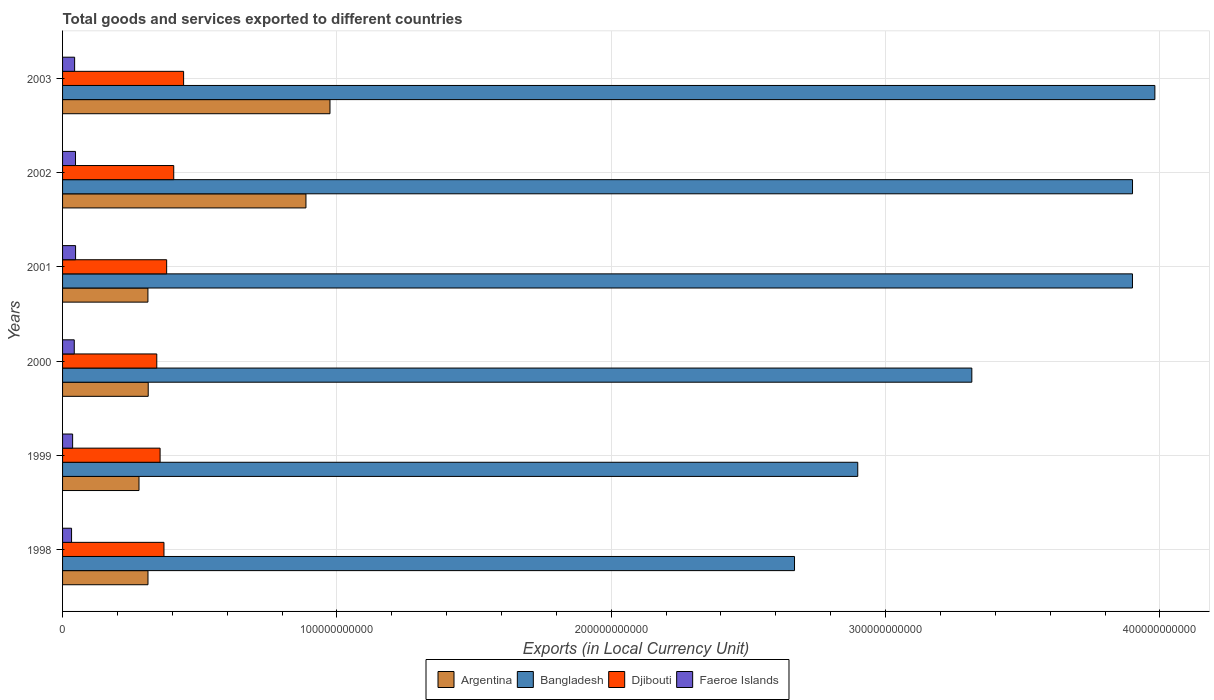Are the number of bars on each tick of the Y-axis equal?
Your response must be concise. Yes. How many bars are there on the 2nd tick from the top?
Keep it short and to the point. 4. How many bars are there on the 6th tick from the bottom?
Your answer should be very brief. 4. What is the label of the 4th group of bars from the top?
Offer a terse response. 2000. In how many cases, is the number of bars for a given year not equal to the number of legend labels?
Keep it short and to the point. 0. What is the Amount of goods and services exports in Djibouti in 2003?
Give a very brief answer. 4.41e+1. Across all years, what is the maximum Amount of goods and services exports in Faeroe Islands?
Your answer should be compact. 4.74e+09. Across all years, what is the minimum Amount of goods and services exports in Bangladesh?
Give a very brief answer. 2.67e+11. What is the total Amount of goods and services exports in Faeroe Islands in the graph?
Make the answer very short. 2.51e+1. What is the difference between the Amount of goods and services exports in Bangladesh in 2002 and that in 2003?
Offer a very short reply. -8.15e+09. What is the difference between the Amount of goods and services exports in Djibouti in 2000 and the Amount of goods and services exports in Faeroe Islands in 2001?
Offer a terse response. 2.96e+1. What is the average Amount of goods and services exports in Faeroe Islands per year?
Keep it short and to the point. 4.18e+09. In the year 1998, what is the difference between the Amount of goods and services exports in Bangladesh and Amount of goods and services exports in Faeroe Islands?
Make the answer very short. 2.64e+11. In how many years, is the Amount of goods and services exports in Argentina greater than 200000000000 LCU?
Make the answer very short. 0. What is the ratio of the Amount of goods and services exports in Bangladesh in 2000 to that in 2002?
Make the answer very short. 0.85. Is the Amount of goods and services exports in Djibouti in 1999 less than that in 2002?
Your response must be concise. Yes. Is the difference between the Amount of goods and services exports in Bangladesh in 1998 and 2003 greater than the difference between the Amount of goods and services exports in Faeroe Islands in 1998 and 2003?
Give a very brief answer. No. What is the difference between the highest and the second highest Amount of goods and services exports in Djibouti?
Your answer should be compact. 3.60e+09. What is the difference between the highest and the lowest Amount of goods and services exports in Djibouti?
Make the answer very short. 9.78e+09. In how many years, is the Amount of goods and services exports in Argentina greater than the average Amount of goods and services exports in Argentina taken over all years?
Give a very brief answer. 2. Is the sum of the Amount of goods and services exports in Faeroe Islands in 1999 and 2001 greater than the maximum Amount of goods and services exports in Argentina across all years?
Your answer should be compact. No. Is it the case that in every year, the sum of the Amount of goods and services exports in Faeroe Islands and Amount of goods and services exports in Djibouti is greater than the sum of Amount of goods and services exports in Argentina and Amount of goods and services exports in Bangladesh?
Give a very brief answer. Yes. What does the 4th bar from the bottom in 2002 represents?
Provide a succinct answer. Faeroe Islands. How many years are there in the graph?
Make the answer very short. 6. What is the difference between two consecutive major ticks on the X-axis?
Provide a succinct answer. 1.00e+11. Are the values on the major ticks of X-axis written in scientific E-notation?
Provide a short and direct response. No. Does the graph contain any zero values?
Offer a very short reply. No. Does the graph contain grids?
Keep it short and to the point. Yes. How are the legend labels stacked?
Your response must be concise. Horizontal. What is the title of the graph?
Ensure brevity in your answer.  Total goods and services exported to different countries. What is the label or title of the X-axis?
Offer a very short reply. Exports (in Local Currency Unit). What is the label or title of the Y-axis?
Provide a short and direct response. Years. What is the Exports (in Local Currency Unit) of Argentina in 1998?
Ensure brevity in your answer.  3.11e+1. What is the Exports (in Local Currency Unit) in Bangladesh in 1998?
Give a very brief answer. 2.67e+11. What is the Exports (in Local Currency Unit) in Djibouti in 1998?
Offer a terse response. 3.70e+1. What is the Exports (in Local Currency Unit) of Faeroe Islands in 1998?
Make the answer very short. 3.28e+09. What is the Exports (in Local Currency Unit) of Argentina in 1999?
Make the answer very short. 2.79e+1. What is the Exports (in Local Currency Unit) of Bangladesh in 1999?
Your response must be concise. 2.90e+11. What is the Exports (in Local Currency Unit) of Djibouti in 1999?
Make the answer very short. 3.56e+1. What is the Exports (in Local Currency Unit) of Faeroe Islands in 1999?
Offer a terse response. 3.66e+09. What is the Exports (in Local Currency Unit) of Argentina in 2000?
Ensure brevity in your answer.  3.12e+1. What is the Exports (in Local Currency Unit) in Bangladesh in 2000?
Offer a terse response. 3.31e+11. What is the Exports (in Local Currency Unit) of Djibouti in 2000?
Keep it short and to the point. 3.43e+1. What is the Exports (in Local Currency Unit) in Faeroe Islands in 2000?
Your answer should be very brief. 4.26e+09. What is the Exports (in Local Currency Unit) in Argentina in 2001?
Provide a succinct answer. 3.11e+1. What is the Exports (in Local Currency Unit) in Bangladesh in 2001?
Provide a succinct answer. 3.90e+11. What is the Exports (in Local Currency Unit) of Djibouti in 2001?
Provide a succinct answer. 3.79e+1. What is the Exports (in Local Currency Unit) in Faeroe Islands in 2001?
Your answer should be very brief. 4.74e+09. What is the Exports (in Local Currency Unit) of Argentina in 2002?
Your response must be concise. 8.87e+1. What is the Exports (in Local Currency Unit) of Bangladesh in 2002?
Provide a succinct answer. 3.90e+11. What is the Exports (in Local Currency Unit) in Djibouti in 2002?
Offer a terse response. 4.05e+1. What is the Exports (in Local Currency Unit) in Faeroe Islands in 2002?
Offer a very short reply. 4.72e+09. What is the Exports (in Local Currency Unit) of Argentina in 2003?
Provide a succinct answer. 9.75e+1. What is the Exports (in Local Currency Unit) of Bangladesh in 2003?
Provide a succinct answer. 3.98e+11. What is the Exports (in Local Currency Unit) in Djibouti in 2003?
Give a very brief answer. 4.41e+1. What is the Exports (in Local Currency Unit) in Faeroe Islands in 2003?
Give a very brief answer. 4.40e+09. Across all years, what is the maximum Exports (in Local Currency Unit) in Argentina?
Provide a succinct answer. 9.75e+1. Across all years, what is the maximum Exports (in Local Currency Unit) in Bangladesh?
Your answer should be compact. 3.98e+11. Across all years, what is the maximum Exports (in Local Currency Unit) in Djibouti?
Offer a very short reply. 4.41e+1. Across all years, what is the maximum Exports (in Local Currency Unit) in Faeroe Islands?
Your response must be concise. 4.74e+09. Across all years, what is the minimum Exports (in Local Currency Unit) of Argentina?
Give a very brief answer. 2.79e+1. Across all years, what is the minimum Exports (in Local Currency Unit) in Bangladesh?
Give a very brief answer. 2.67e+11. Across all years, what is the minimum Exports (in Local Currency Unit) in Djibouti?
Your answer should be compact. 3.43e+1. Across all years, what is the minimum Exports (in Local Currency Unit) of Faeroe Islands?
Make the answer very short. 3.28e+09. What is the total Exports (in Local Currency Unit) of Argentina in the graph?
Your response must be concise. 3.08e+11. What is the total Exports (in Local Currency Unit) in Bangladesh in the graph?
Your answer should be very brief. 2.07e+12. What is the total Exports (in Local Currency Unit) in Djibouti in the graph?
Your response must be concise. 2.29e+11. What is the total Exports (in Local Currency Unit) of Faeroe Islands in the graph?
Provide a succinct answer. 2.51e+1. What is the difference between the Exports (in Local Currency Unit) of Argentina in 1998 and that in 1999?
Make the answer very short. 3.27e+09. What is the difference between the Exports (in Local Currency Unit) in Bangladesh in 1998 and that in 1999?
Offer a terse response. -2.31e+1. What is the difference between the Exports (in Local Currency Unit) in Djibouti in 1998 and that in 1999?
Give a very brief answer. 1.41e+09. What is the difference between the Exports (in Local Currency Unit) in Faeroe Islands in 1998 and that in 1999?
Ensure brevity in your answer.  -3.83e+08. What is the difference between the Exports (in Local Currency Unit) of Argentina in 1998 and that in 2000?
Make the answer very short. -8.68e+07. What is the difference between the Exports (in Local Currency Unit) in Bangladesh in 1998 and that in 2000?
Provide a short and direct response. -6.46e+1. What is the difference between the Exports (in Local Currency Unit) in Djibouti in 1998 and that in 2000?
Ensure brevity in your answer.  2.62e+09. What is the difference between the Exports (in Local Currency Unit) in Faeroe Islands in 1998 and that in 2000?
Provide a short and direct response. -9.84e+08. What is the difference between the Exports (in Local Currency Unit) in Argentina in 1998 and that in 2001?
Ensure brevity in your answer.  2.42e+07. What is the difference between the Exports (in Local Currency Unit) in Bangladesh in 1998 and that in 2001?
Offer a terse response. -1.23e+11. What is the difference between the Exports (in Local Currency Unit) in Djibouti in 1998 and that in 2001?
Your response must be concise. -9.75e+08. What is the difference between the Exports (in Local Currency Unit) in Faeroe Islands in 1998 and that in 2001?
Give a very brief answer. -1.46e+09. What is the difference between the Exports (in Local Currency Unit) in Argentina in 1998 and that in 2002?
Make the answer very short. -5.76e+1. What is the difference between the Exports (in Local Currency Unit) of Bangladesh in 1998 and that in 2002?
Keep it short and to the point. -1.23e+11. What is the difference between the Exports (in Local Currency Unit) of Djibouti in 1998 and that in 2002?
Offer a very short reply. -3.56e+09. What is the difference between the Exports (in Local Currency Unit) of Faeroe Islands in 1998 and that in 2002?
Provide a succinct answer. -1.44e+09. What is the difference between the Exports (in Local Currency Unit) of Argentina in 1998 and that in 2003?
Keep it short and to the point. -6.63e+1. What is the difference between the Exports (in Local Currency Unit) of Bangladesh in 1998 and that in 2003?
Offer a terse response. -1.31e+11. What is the difference between the Exports (in Local Currency Unit) of Djibouti in 1998 and that in 2003?
Provide a short and direct response. -7.16e+09. What is the difference between the Exports (in Local Currency Unit) in Faeroe Islands in 1998 and that in 2003?
Offer a very short reply. -1.12e+09. What is the difference between the Exports (in Local Currency Unit) in Argentina in 1999 and that in 2000?
Your response must be concise. -3.36e+09. What is the difference between the Exports (in Local Currency Unit) in Bangladesh in 1999 and that in 2000?
Your response must be concise. -4.16e+1. What is the difference between the Exports (in Local Currency Unit) of Djibouti in 1999 and that in 2000?
Keep it short and to the point. 1.21e+09. What is the difference between the Exports (in Local Currency Unit) of Faeroe Islands in 1999 and that in 2000?
Ensure brevity in your answer.  -6.01e+08. What is the difference between the Exports (in Local Currency Unit) of Argentina in 1999 and that in 2001?
Offer a terse response. -3.25e+09. What is the difference between the Exports (in Local Currency Unit) in Bangladesh in 1999 and that in 2001?
Give a very brief answer. -1.00e+11. What is the difference between the Exports (in Local Currency Unit) in Djibouti in 1999 and that in 2001?
Keep it short and to the point. -2.39e+09. What is the difference between the Exports (in Local Currency Unit) in Faeroe Islands in 1999 and that in 2001?
Provide a short and direct response. -1.08e+09. What is the difference between the Exports (in Local Currency Unit) in Argentina in 1999 and that in 2002?
Provide a succinct answer. -6.09e+1. What is the difference between the Exports (in Local Currency Unit) in Bangladesh in 1999 and that in 2002?
Provide a short and direct response. -1.00e+11. What is the difference between the Exports (in Local Currency Unit) of Djibouti in 1999 and that in 2002?
Ensure brevity in your answer.  -4.97e+09. What is the difference between the Exports (in Local Currency Unit) in Faeroe Islands in 1999 and that in 2002?
Provide a succinct answer. -1.06e+09. What is the difference between the Exports (in Local Currency Unit) in Argentina in 1999 and that in 2003?
Make the answer very short. -6.96e+1. What is the difference between the Exports (in Local Currency Unit) of Bangladesh in 1999 and that in 2003?
Ensure brevity in your answer.  -1.08e+11. What is the difference between the Exports (in Local Currency Unit) in Djibouti in 1999 and that in 2003?
Give a very brief answer. -8.57e+09. What is the difference between the Exports (in Local Currency Unit) of Faeroe Islands in 1999 and that in 2003?
Your response must be concise. -7.34e+08. What is the difference between the Exports (in Local Currency Unit) of Argentina in 2000 and that in 2001?
Your answer should be compact. 1.11e+08. What is the difference between the Exports (in Local Currency Unit) of Bangladesh in 2000 and that in 2001?
Provide a succinct answer. -5.86e+1. What is the difference between the Exports (in Local Currency Unit) of Djibouti in 2000 and that in 2001?
Make the answer very short. -3.60e+09. What is the difference between the Exports (in Local Currency Unit) in Faeroe Islands in 2000 and that in 2001?
Ensure brevity in your answer.  -4.78e+08. What is the difference between the Exports (in Local Currency Unit) in Argentina in 2000 and that in 2002?
Offer a terse response. -5.75e+1. What is the difference between the Exports (in Local Currency Unit) in Bangladesh in 2000 and that in 2002?
Keep it short and to the point. -5.86e+1. What is the difference between the Exports (in Local Currency Unit) in Djibouti in 2000 and that in 2002?
Your response must be concise. -6.18e+09. What is the difference between the Exports (in Local Currency Unit) of Faeroe Islands in 2000 and that in 2002?
Provide a short and direct response. -4.54e+08. What is the difference between the Exports (in Local Currency Unit) in Argentina in 2000 and that in 2003?
Give a very brief answer. -6.63e+1. What is the difference between the Exports (in Local Currency Unit) of Bangladesh in 2000 and that in 2003?
Keep it short and to the point. -6.67e+1. What is the difference between the Exports (in Local Currency Unit) in Djibouti in 2000 and that in 2003?
Your answer should be compact. -9.78e+09. What is the difference between the Exports (in Local Currency Unit) of Faeroe Islands in 2000 and that in 2003?
Provide a short and direct response. -1.33e+08. What is the difference between the Exports (in Local Currency Unit) of Argentina in 2001 and that in 2002?
Provide a succinct answer. -5.76e+1. What is the difference between the Exports (in Local Currency Unit) of Bangladesh in 2001 and that in 2002?
Make the answer very short. -2.10e+07. What is the difference between the Exports (in Local Currency Unit) of Djibouti in 2001 and that in 2002?
Your answer should be compact. -2.58e+09. What is the difference between the Exports (in Local Currency Unit) of Faeroe Islands in 2001 and that in 2002?
Provide a short and direct response. 2.40e+07. What is the difference between the Exports (in Local Currency Unit) of Argentina in 2001 and that in 2003?
Your answer should be compact. -6.64e+1. What is the difference between the Exports (in Local Currency Unit) of Bangladesh in 2001 and that in 2003?
Provide a succinct answer. -8.17e+09. What is the difference between the Exports (in Local Currency Unit) in Djibouti in 2001 and that in 2003?
Your response must be concise. -6.18e+09. What is the difference between the Exports (in Local Currency Unit) of Faeroe Islands in 2001 and that in 2003?
Provide a succinct answer. 3.45e+08. What is the difference between the Exports (in Local Currency Unit) in Argentina in 2002 and that in 2003?
Offer a very short reply. -8.76e+09. What is the difference between the Exports (in Local Currency Unit) in Bangladesh in 2002 and that in 2003?
Your response must be concise. -8.15e+09. What is the difference between the Exports (in Local Currency Unit) of Djibouti in 2002 and that in 2003?
Offer a terse response. -3.60e+09. What is the difference between the Exports (in Local Currency Unit) of Faeroe Islands in 2002 and that in 2003?
Ensure brevity in your answer.  3.21e+08. What is the difference between the Exports (in Local Currency Unit) in Argentina in 1998 and the Exports (in Local Currency Unit) in Bangladesh in 1999?
Keep it short and to the point. -2.59e+11. What is the difference between the Exports (in Local Currency Unit) of Argentina in 1998 and the Exports (in Local Currency Unit) of Djibouti in 1999?
Your answer should be very brief. -4.42e+09. What is the difference between the Exports (in Local Currency Unit) of Argentina in 1998 and the Exports (in Local Currency Unit) of Faeroe Islands in 1999?
Provide a short and direct response. 2.75e+1. What is the difference between the Exports (in Local Currency Unit) in Bangladesh in 1998 and the Exports (in Local Currency Unit) in Djibouti in 1999?
Provide a short and direct response. 2.31e+11. What is the difference between the Exports (in Local Currency Unit) in Bangladesh in 1998 and the Exports (in Local Currency Unit) in Faeroe Islands in 1999?
Your answer should be very brief. 2.63e+11. What is the difference between the Exports (in Local Currency Unit) in Djibouti in 1998 and the Exports (in Local Currency Unit) in Faeroe Islands in 1999?
Provide a succinct answer. 3.33e+1. What is the difference between the Exports (in Local Currency Unit) of Argentina in 1998 and the Exports (in Local Currency Unit) of Bangladesh in 2000?
Offer a very short reply. -3.00e+11. What is the difference between the Exports (in Local Currency Unit) in Argentina in 1998 and the Exports (in Local Currency Unit) in Djibouti in 2000?
Provide a short and direct response. -3.21e+09. What is the difference between the Exports (in Local Currency Unit) of Argentina in 1998 and the Exports (in Local Currency Unit) of Faeroe Islands in 2000?
Offer a terse response. 2.69e+1. What is the difference between the Exports (in Local Currency Unit) of Bangladesh in 1998 and the Exports (in Local Currency Unit) of Djibouti in 2000?
Offer a very short reply. 2.32e+11. What is the difference between the Exports (in Local Currency Unit) in Bangladesh in 1998 and the Exports (in Local Currency Unit) in Faeroe Islands in 2000?
Your answer should be very brief. 2.63e+11. What is the difference between the Exports (in Local Currency Unit) in Djibouti in 1998 and the Exports (in Local Currency Unit) in Faeroe Islands in 2000?
Your answer should be very brief. 3.27e+1. What is the difference between the Exports (in Local Currency Unit) of Argentina in 1998 and the Exports (in Local Currency Unit) of Bangladesh in 2001?
Offer a very short reply. -3.59e+11. What is the difference between the Exports (in Local Currency Unit) in Argentina in 1998 and the Exports (in Local Currency Unit) in Djibouti in 2001?
Keep it short and to the point. -6.80e+09. What is the difference between the Exports (in Local Currency Unit) in Argentina in 1998 and the Exports (in Local Currency Unit) in Faeroe Islands in 2001?
Your answer should be compact. 2.64e+1. What is the difference between the Exports (in Local Currency Unit) in Bangladesh in 1998 and the Exports (in Local Currency Unit) in Djibouti in 2001?
Your answer should be compact. 2.29e+11. What is the difference between the Exports (in Local Currency Unit) in Bangladesh in 1998 and the Exports (in Local Currency Unit) in Faeroe Islands in 2001?
Provide a succinct answer. 2.62e+11. What is the difference between the Exports (in Local Currency Unit) in Djibouti in 1998 and the Exports (in Local Currency Unit) in Faeroe Islands in 2001?
Your answer should be compact. 3.22e+1. What is the difference between the Exports (in Local Currency Unit) of Argentina in 1998 and the Exports (in Local Currency Unit) of Bangladesh in 2002?
Your answer should be very brief. -3.59e+11. What is the difference between the Exports (in Local Currency Unit) in Argentina in 1998 and the Exports (in Local Currency Unit) in Djibouti in 2002?
Your answer should be compact. -9.38e+09. What is the difference between the Exports (in Local Currency Unit) of Argentina in 1998 and the Exports (in Local Currency Unit) of Faeroe Islands in 2002?
Keep it short and to the point. 2.64e+1. What is the difference between the Exports (in Local Currency Unit) in Bangladesh in 1998 and the Exports (in Local Currency Unit) in Djibouti in 2002?
Offer a very short reply. 2.26e+11. What is the difference between the Exports (in Local Currency Unit) in Bangladesh in 1998 and the Exports (in Local Currency Unit) in Faeroe Islands in 2002?
Provide a short and direct response. 2.62e+11. What is the difference between the Exports (in Local Currency Unit) of Djibouti in 1998 and the Exports (in Local Currency Unit) of Faeroe Islands in 2002?
Keep it short and to the point. 3.22e+1. What is the difference between the Exports (in Local Currency Unit) in Argentina in 1998 and the Exports (in Local Currency Unit) in Bangladesh in 2003?
Provide a short and direct response. -3.67e+11. What is the difference between the Exports (in Local Currency Unit) of Argentina in 1998 and the Exports (in Local Currency Unit) of Djibouti in 2003?
Provide a short and direct response. -1.30e+1. What is the difference between the Exports (in Local Currency Unit) of Argentina in 1998 and the Exports (in Local Currency Unit) of Faeroe Islands in 2003?
Ensure brevity in your answer.  2.67e+1. What is the difference between the Exports (in Local Currency Unit) of Bangladesh in 1998 and the Exports (in Local Currency Unit) of Djibouti in 2003?
Your response must be concise. 2.23e+11. What is the difference between the Exports (in Local Currency Unit) in Bangladesh in 1998 and the Exports (in Local Currency Unit) in Faeroe Islands in 2003?
Your answer should be very brief. 2.62e+11. What is the difference between the Exports (in Local Currency Unit) in Djibouti in 1998 and the Exports (in Local Currency Unit) in Faeroe Islands in 2003?
Provide a short and direct response. 3.26e+1. What is the difference between the Exports (in Local Currency Unit) in Argentina in 1999 and the Exports (in Local Currency Unit) in Bangladesh in 2000?
Give a very brief answer. -3.04e+11. What is the difference between the Exports (in Local Currency Unit) of Argentina in 1999 and the Exports (in Local Currency Unit) of Djibouti in 2000?
Provide a short and direct response. -6.48e+09. What is the difference between the Exports (in Local Currency Unit) of Argentina in 1999 and the Exports (in Local Currency Unit) of Faeroe Islands in 2000?
Your answer should be very brief. 2.36e+1. What is the difference between the Exports (in Local Currency Unit) of Bangladesh in 1999 and the Exports (in Local Currency Unit) of Djibouti in 2000?
Your response must be concise. 2.56e+11. What is the difference between the Exports (in Local Currency Unit) of Bangladesh in 1999 and the Exports (in Local Currency Unit) of Faeroe Islands in 2000?
Provide a succinct answer. 2.86e+11. What is the difference between the Exports (in Local Currency Unit) in Djibouti in 1999 and the Exports (in Local Currency Unit) in Faeroe Islands in 2000?
Keep it short and to the point. 3.13e+1. What is the difference between the Exports (in Local Currency Unit) of Argentina in 1999 and the Exports (in Local Currency Unit) of Bangladesh in 2001?
Provide a short and direct response. -3.62e+11. What is the difference between the Exports (in Local Currency Unit) in Argentina in 1999 and the Exports (in Local Currency Unit) in Djibouti in 2001?
Give a very brief answer. -1.01e+1. What is the difference between the Exports (in Local Currency Unit) of Argentina in 1999 and the Exports (in Local Currency Unit) of Faeroe Islands in 2001?
Make the answer very short. 2.31e+1. What is the difference between the Exports (in Local Currency Unit) of Bangladesh in 1999 and the Exports (in Local Currency Unit) of Djibouti in 2001?
Provide a short and direct response. 2.52e+11. What is the difference between the Exports (in Local Currency Unit) of Bangladesh in 1999 and the Exports (in Local Currency Unit) of Faeroe Islands in 2001?
Provide a short and direct response. 2.85e+11. What is the difference between the Exports (in Local Currency Unit) in Djibouti in 1999 and the Exports (in Local Currency Unit) in Faeroe Islands in 2001?
Your response must be concise. 3.08e+1. What is the difference between the Exports (in Local Currency Unit) in Argentina in 1999 and the Exports (in Local Currency Unit) in Bangladesh in 2002?
Provide a succinct answer. -3.62e+11. What is the difference between the Exports (in Local Currency Unit) in Argentina in 1999 and the Exports (in Local Currency Unit) in Djibouti in 2002?
Your response must be concise. -1.27e+1. What is the difference between the Exports (in Local Currency Unit) of Argentina in 1999 and the Exports (in Local Currency Unit) of Faeroe Islands in 2002?
Ensure brevity in your answer.  2.31e+1. What is the difference between the Exports (in Local Currency Unit) of Bangladesh in 1999 and the Exports (in Local Currency Unit) of Djibouti in 2002?
Provide a short and direct response. 2.49e+11. What is the difference between the Exports (in Local Currency Unit) in Bangladesh in 1999 and the Exports (in Local Currency Unit) in Faeroe Islands in 2002?
Provide a succinct answer. 2.85e+11. What is the difference between the Exports (in Local Currency Unit) of Djibouti in 1999 and the Exports (in Local Currency Unit) of Faeroe Islands in 2002?
Provide a succinct answer. 3.08e+1. What is the difference between the Exports (in Local Currency Unit) of Argentina in 1999 and the Exports (in Local Currency Unit) of Bangladesh in 2003?
Your response must be concise. -3.70e+11. What is the difference between the Exports (in Local Currency Unit) of Argentina in 1999 and the Exports (in Local Currency Unit) of Djibouti in 2003?
Offer a very short reply. -1.63e+1. What is the difference between the Exports (in Local Currency Unit) of Argentina in 1999 and the Exports (in Local Currency Unit) of Faeroe Islands in 2003?
Offer a very short reply. 2.35e+1. What is the difference between the Exports (in Local Currency Unit) in Bangladesh in 1999 and the Exports (in Local Currency Unit) in Djibouti in 2003?
Give a very brief answer. 2.46e+11. What is the difference between the Exports (in Local Currency Unit) of Bangladesh in 1999 and the Exports (in Local Currency Unit) of Faeroe Islands in 2003?
Make the answer very short. 2.85e+11. What is the difference between the Exports (in Local Currency Unit) of Djibouti in 1999 and the Exports (in Local Currency Unit) of Faeroe Islands in 2003?
Provide a short and direct response. 3.12e+1. What is the difference between the Exports (in Local Currency Unit) in Argentina in 2000 and the Exports (in Local Currency Unit) in Bangladesh in 2001?
Make the answer very short. -3.59e+11. What is the difference between the Exports (in Local Currency Unit) in Argentina in 2000 and the Exports (in Local Currency Unit) in Djibouti in 2001?
Make the answer very short. -6.72e+09. What is the difference between the Exports (in Local Currency Unit) of Argentina in 2000 and the Exports (in Local Currency Unit) of Faeroe Islands in 2001?
Your answer should be compact. 2.65e+1. What is the difference between the Exports (in Local Currency Unit) of Bangladesh in 2000 and the Exports (in Local Currency Unit) of Djibouti in 2001?
Provide a succinct answer. 2.94e+11. What is the difference between the Exports (in Local Currency Unit) of Bangladesh in 2000 and the Exports (in Local Currency Unit) of Faeroe Islands in 2001?
Your answer should be very brief. 3.27e+11. What is the difference between the Exports (in Local Currency Unit) of Djibouti in 2000 and the Exports (in Local Currency Unit) of Faeroe Islands in 2001?
Offer a terse response. 2.96e+1. What is the difference between the Exports (in Local Currency Unit) in Argentina in 2000 and the Exports (in Local Currency Unit) in Bangladesh in 2002?
Give a very brief answer. -3.59e+11. What is the difference between the Exports (in Local Currency Unit) of Argentina in 2000 and the Exports (in Local Currency Unit) of Djibouti in 2002?
Provide a succinct answer. -9.30e+09. What is the difference between the Exports (in Local Currency Unit) of Argentina in 2000 and the Exports (in Local Currency Unit) of Faeroe Islands in 2002?
Offer a terse response. 2.65e+1. What is the difference between the Exports (in Local Currency Unit) in Bangladesh in 2000 and the Exports (in Local Currency Unit) in Djibouti in 2002?
Provide a succinct answer. 2.91e+11. What is the difference between the Exports (in Local Currency Unit) in Bangladesh in 2000 and the Exports (in Local Currency Unit) in Faeroe Islands in 2002?
Keep it short and to the point. 3.27e+11. What is the difference between the Exports (in Local Currency Unit) in Djibouti in 2000 and the Exports (in Local Currency Unit) in Faeroe Islands in 2002?
Your response must be concise. 2.96e+1. What is the difference between the Exports (in Local Currency Unit) of Argentina in 2000 and the Exports (in Local Currency Unit) of Bangladesh in 2003?
Keep it short and to the point. -3.67e+11. What is the difference between the Exports (in Local Currency Unit) of Argentina in 2000 and the Exports (in Local Currency Unit) of Djibouti in 2003?
Offer a very short reply. -1.29e+1. What is the difference between the Exports (in Local Currency Unit) of Argentina in 2000 and the Exports (in Local Currency Unit) of Faeroe Islands in 2003?
Ensure brevity in your answer.  2.68e+1. What is the difference between the Exports (in Local Currency Unit) of Bangladesh in 2000 and the Exports (in Local Currency Unit) of Djibouti in 2003?
Ensure brevity in your answer.  2.87e+11. What is the difference between the Exports (in Local Currency Unit) of Bangladesh in 2000 and the Exports (in Local Currency Unit) of Faeroe Islands in 2003?
Your answer should be very brief. 3.27e+11. What is the difference between the Exports (in Local Currency Unit) of Djibouti in 2000 and the Exports (in Local Currency Unit) of Faeroe Islands in 2003?
Your answer should be compact. 2.99e+1. What is the difference between the Exports (in Local Currency Unit) of Argentina in 2001 and the Exports (in Local Currency Unit) of Bangladesh in 2002?
Give a very brief answer. -3.59e+11. What is the difference between the Exports (in Local Currency Unit) in Argentina in 2001 and the Exports (in Local Currency Unit) in Djibouti in 2002?
Give a very brief answer. -9.41e+09. What is the difference between the Exports (in Local Currency Unit) in Argentina in 2001 and the Exports (in Local Currency Unit) in Faeroe Islands in 2002?
Your response must be concise. 2.64e+1. What is the difference between the Exports (in Local Currency Unit) of Bangladesh in 2001 and the Exports (in Local Currency Unit) of Djibouti in 2002?
Keep it short and to the point. 3.49e+11. What is the difference between the Exports (in Local Currency Unit) in Bangladesh in 2001 and the Exports (in Local Currency Unit) in Faeroe Islands in 2002?
Give a very brief answer. 3.85e+11. What is the difference between the Exports (in Local Currency Unit) of Djibouti in 2001 and the Exports (in Local Currency Unit) of Faeroe Islands in 2002?
Make the answer very short. 3.32e+1. What is the difference between the Exports (in Local Currency Unit) of Argentina in 2001 and the Exports (in Local Currency Unit) of Bangladesh in 2003?
Keep it short and to the point. -3.67e+11. What is the difference between the Exports (in Local Currency Unit) in Argentina in 2001 and the Exports (in Local Currency Unit) in Djibouti in 2003?
Your answer should be very brief. -1.30e+1. What is the difference between the Exports (in Local Currency Unit) in Argentina in 2001 and the Exports (in Local Currency Unit) in Faeroe Islands in 2003?
Give a very brief answer. 2.67e+1. What is the difference between the Exports (in Local Currency Unit) of Bangladesh in 2001 and the Exports (in Local Currency Unit) of Djibouti in 2003?
Offer a terse response. 3.46e+11. What is the difference between the Exports (in Local Currency Unit) in Bangladesh in 2001 and the Exports (in Local Currency Unit) in Faeroe Islands in 2003?
Ensure brevity in your answer.  3.86e+11. What is the difference between the Exports (in Local Currency Unit) of Djibouti in 2001 and the Exports (in Local Currency Unit) of Faeroe Islands in 2003?
Provide a succinct answer. 3.35e+1. What is the difference between the Exports (in Local Currency Unit) of Argentina in 2002 and the Exports (in Local Currency Unit) of Bangladesh in 2003?
Your answer should be very brief. -3.09e+11. What is the difference between the Exports (in Local Currency Unit) of Argentina in 2002 and the Exports (in Local Currency Unit) of Djibouti in 2003?
Provide a short and direct response. 4.46e+1. What is the difference between the Exports (in Local Currency Unit) in Argentina in 2002 and the Exports (in Local Currency Unit) in Faeroe Islands in 2003?
Make the answer very short. 8.43e+1. What is the difference between the Exports (in Local Currency Unit) in Bangladesh in 2002 and the Exports (in Local Currency Unit) in Djibouti in 2003?
Offer a terse response. 3.46e+11. What is the difference between the Exports (in Local Currency Unit) of Bangladesh in 2002 and the Exports (in Local Currency Unit) of Faeroe Islands in 2003?
Your answer should be very brief. 3.86e+11. What is the difference between the Exports (in Local Currency Unit) of Djibouti in 2002 and the Exports (in Local Currency Unit) of Faeroe Islands in 2003?
Your response must be concise. 3.61e+1. What is the average Exports (in Local Currency Unit) of Argentina per year?
Ensure brevity in your answer.  5.13e+1. What is the average Exports (in Local Currency Unit) in Bangladesh per year?
Give a very brief answer. 3.44e+11. What is the average Exports (in Local Currency Unit) of Djibouti per year?
Offer a very short reply. 3.82e+1. What is the average Exports (in Local Currency Unit) of Faeroe Islands per year?
Provide a short and direct response. 4.18e+09. In the year 1998, what is the difference between the Exports (in Local Currency Unit) in Argentina and Exports (in Local Currency Unit) in Bangladesh?
Offer a very short reply. -2.36e+11. In the year 1998, what is the difference between the Exports (in Local Currency Unit) in Argentina and Exports (in Local Currency Unit) in Djibouti?
Offer a very short reply. -5.83e+09. In the year 1998, what is the difference between the Exports (in Local Currency Unit) of Argentina and Exports (in Local Currency Unit) of Faeroe Islands?
Your answer should be very brief. 2.79e+1. In the year 1998, what is the difference between the Exports (in Local Currency Unit) in Bangladesh and Exports (in Local Currency Unit) in Djibouti?
Your answer should be very brief. 2.30e+11. In the year 1998, what is the difference between the Exports (in Local Currency Unit) in Bangladesh and Exports (in Local Currency Unit) in Faeroe Islands?
Your answer should be very brief. 2.64e+11. In the year 1998, what is the difference between the Exports (in Local Currency Unit) in Djibouti and Exports (in Local Currency Unit) in Faeroe Islands?
Provide a short and direct response. 3.37e+1. In the year 1999, what is the difference between the Exports (in Local Currency Unit) of Argentina and Exports (in Local Currency Unit) of Bangladesh?
Provide a short and direct response. -2.62e+11. In the year 1999, what is the difference between the Exports (in Local Currency Unit) of Argentina and Exports (in Local Currency Unit) of Djibouti?
Provide a short and direct response. -7.69e+09. In the year 1999, what is the difference between the Exports (in Local Currency Unit) in Argentina and Exports (in Local Currency Unit) in Faeroe Islands?
Your response must be concise. 2.42e+1. In the year 1999, what is the difference between the Exports (in Local Currency Unit) of Bangladesh and Exports (in Local Currency Unit) of Djibouti?
Offer a very short reply. 2.54e+11. In the year 1999, what is the difference between the Exports (in Local Currency Unit) in Bangladesh and Exports (in Local Currency Unit) in Faeroe Islands?
Provide a short and direct response. 2.86e+11. In the year 1999, what is the difference between the Exports (in Local Currency Unit) in Djibouti and Exports (in Local Currency Unit) in Faeroe Islands?
Offer a terse response. 3.19e+1. In the year 2000, what is the difference between the Exports (in Local Currency Unit) in Argentina and Exports (in Local Currency Unit) in Bangladesh?
Your answer should be compact. -3.00e+11. In the year 2000, what is the difference between the Exports (in Local Currency Unit) of Argentina and Exports (in Local Currency Unit) of Djibouti?
Keep it short and to the point. -3.12e+09. In the year 2000, what is the difference between the Exports (in Local Currency Unit) in Argentina and Exports (in Local Currency Unit) in Faeroe Islands?
Offer a terse response. 2.70e+1. In the year 2000, what is the difference between the Exports (in Local Currency Unit) in Bangladesh and Exports (in Local Currency Unit) in Djibouti?
Make the answer very short. 2.97e+11. In the year 2000, what is the difference between the Exports (in Local Currency Unit) in Bangladesh and Exports (in Local Currency Unit) in Faeroe Islands?
Provide a succinct answer. 3.27e+11. In the year 2000, what is the difference between the Exports (in Local Currency Unit) in Djibouti and Exports (in Local Currency Unit) in Faeroe Islands?
Give a very brief answer. 3.01e+1. In the year 2001, what is the difference between the Exports (in Local Currency Unit) of Argentina and Exports (in Local Currency Unit) of Bangladesh?
Provide a succinct answer. -3.59e+11. In the year 2001, what is the difference between the Exports (in Local Currency Unit) in Argentina and Exports (in Local Currency Unit) in Djibouti?
Ensure brevity in your answer.  -6.83e+09. In the year 2001, what is the difference between the Exports (in Local Currency Unit) in Argentina and Exports (in Local Currency Unit) in Faeroe Islands?
Offer a very short reply. 2.64e+1. In the year 2001, what is the difference between the Exports (in Local Currency Unit) in Bangladesh and Exports (in Local Currency Unit) in Djibouti?
Provide a succinct answer. 3.52e+11. In the year 2001, what is the difference between the Exports (in Local Currency Unit) in Bangladesh and Exports (in Local Currency Unit) in Faeroe Islands?
Give a very brief answer. 3.85e+11. In the year 2001, what is the difference between the Exports (in Local Currency Unit) of Djibouti and Exports (in Local Currency Unit) of Faeroe Islands?
Your response must be concise. 3.32e+1. In the year 2002, what is the difference between the Exports (in Local Currency Unit) of Argentina and Exports (in Local Currency Unit) of Bangladesh?
Keep it short and to the point. -3.01e+11. In the year 2002, what is the difference between the Exports (in Local Currency Unit) of Argentina and Exports (in Local Currency Unit) of Djibouti?
Offer a very short reply. 4.82e+1. In the year 2002, what is the difference between the Exports (in Local Currency Unit) in Argentina and Exports (in Local Currency Unit) in Faeroe Islands?
Make the answer very short. 8.40e+1. In the year 2002, what is the difference between the Exports (in Local Currency Unit) of Bangladesh and Exports (in Local Currency Unit) of Djibouti?
Ensure brevity in your answer.  3.50e+11. In the year 2002, what is the difference between the Exports (in Local Currency Unit) of Bangladesh and Exports (in Local Currency Unit) of Faeroe Islands?
Ensure brevity in your answer.  3.85e+11. In the year 2002, what is the difference between the Exports (in Local Currency Unit) of Djibouti and Exports (in Local Currency Unit) of Faeroe Islands?
Offer a terse response. 3.58e+1. In the year 2003, what is the difference between the Exports (in Local Currency Unit) of Argentina and Exports (in Local Currency Unit) of Bangladesh?
Give a very brief answer. -3.01e+11. In the year 2003, what is the difference between the Exports (in Local Currency Unit) in Argentina and Exports (in Local Currency Unit) in Djibouti?
Provide a succinct answer. 5.34e+1. In the year 2003, what is the difference between the Exports (in Local Currency Unit) in Argentina and Exports (in Local Currency Unit) in Faeroe Islands?
Provide a short and direct response. 9.31e+1. In the year 2003, what is the difference between the Exports (in Local Currency Unit) in Bangladesh and Exports (in Local Currency Unit) in Djibouti?
Offer a very short reply. 3.54e+11. In the year 2003, what is the difference between the Exports (in Local Currency Unit) of Bangladesh and Exports (in Local Currency Unit) of Faeroe Islands?
Give a very brief answer. 3.94e+11. In the year 2003, what is the difference between the Exports (in Local Currency Unit) of Djibouti and Exports (in Local Currency Unit) of Faeroe Islands?
Offer a terse response. 3.97e+1. What is the ratio of the Exports (in Local Currency Unit) of Argentina in 1998 to that in 1999?
Offer a very short reply. 1.12. What is the ratio of the Exports (in Local Currency Unit) in Bangladesh in 1998 to that in 1999?
Your response must be concise. 0.92. What is the ratio of the Exports (in Local Currency Unit) of Djibouti in 1998 to that in 1999?
Your answer should be very brief. 1.04. What is the ratio of the Exports (in Local Currency Unit) of Faeroe Islands in 1998 to that in 1999?
Your response must be concise. 0.9. What is the ratio of the Exports (in Local Currency Unit) in Argentina in 1998 to that in 2000?
Ensure brevity in your answer.  1. What is the ratio of the Exports (in Local Currency Unit) of Bangladesh in 1998 to that in 2000?
Your answer should be very brief. 0.81. What is the ratio of the Exports (in Local Currency Unit) in Djibouti in 1998 to that in 2000?
Make the answer very short. 1.08. What is the ratio of the Exports (in Local Currency Unit) of Faeroe Islands in 1998 to that in 2000?
Keep it short and to the point. 0.77. What is the ratio of the Exports (in Local Currency Unit) of Argentina in 1998 to that in 2001?
Offer a very short reply. 1. What is the ratio of the Exports (in Local Currency Unit) in Bangladesh in 1998 to that in 2001?
Your response must be concise. 0.68. What is the ratio of the Exports (in Local Currency Unit) in Djibouti in 1998 to that in 2001?
Ensure brevity in your answer.  0.97. What is the ratio of the Exports (in Local Currency Unit) of Faeroe Islands in 1998 to that in 2001?
Give a very brief answer. 0.69. What is the ratio of the Exports (in Local Currency Unit) in Argentina in 1998 to that in 2002?
Make the answer very short. 0.35. What is the ratio of the Exports (in Local Currency Unit) in Bangladesh in 1998 to that in 2002?
Your answer should be compact. 0.68. What is the ratio of the Exports (in Local Currency Unit) in Djibouti in 1998 to that in 2002?
Provide a short and direct response. 0.91. What is the ratio of the Exports (in Local Currency Unit) in Faeroe Islands in 1998 to that in 2002?
Give a very brief answer. 0.7. What is the ratio of the Exports (in Local Currency Unit) in Argentina in 1998 to that in 2003?
Offer a terse response. 0.32. What is the ratio of the Exports (in Local Currency Unit) in Bangladesh in 1998 to that in 2003?
Offer a terse response. 0.67. What is the ratio of the Exports (in Local Currency Unit) in Djibouti in 1998 to that in 2003?
Make the answer very short. 0.84. What is the ratio of the Exports (in Local Currency Unit) of Faeroe Islands in 1998 to that in 2003?
Your response must be concise. 0.75. What is the ratio of the Exports (in Local Currency Unit) in Argentina in 1999 to that in 2000?
Give a very brief answer. 0.89. What is the ratio of the Exports (in Local Currency Unit) of Bangladesh in 1999 to that in 2000?
Provide a succinct answer. 0.87. What is the ratio of the Exports (in Local Currency Unit) of Djibouti in 1999 to that in 2000?
Provide a succinct answer. 1.04. What is the ratio of the Exports (in Local Currency Unit) of Faeroe Islands in 1999 to that in 2000?
Keep it short and to the point. 0.86. What is the ratio of the Exports (in Local Currency Unit) in Argentina in 1999 to that in 2001?
Provide a short and direct response. 0.9. What is the ratio of the Exports (in Local Currency Unit) of Bangladesh in 1999 to that in 2001?
Keep it short and to the point. 0.74. What is the ratio of the Exports (in Local Currency Unit) of Djibouti in 1999 to that in 2001?
Your answer should be very brief. 0.94. What is the ratio of the Exports (in Local Currency Unit) in Faeroe Islands in 1999 to that in 2001?
Provide a short and direct response. 0.77. What is the ratio of the Exports (in Local Currency Unit) of Argentina in 1999 to that in 2002?
Ensure brevity in your answer.  0.31. What is the ratio of the Exports (in Local Currency Unit) of Bangladesh in 1999 to that in 2002?
Provide a succinct answer. 0.74. What is the ratio of the Exports (in Local Currency Unit) in Djibouti in 1999 to that in 2002?
Ensure brevity in your answer.  0.88. What is the ratio of the Exports (in Local Currency Unit) of Faeroe Islands in 1999 to that in 2002?
Your response must be concise. 0.78. What is the ratio of the Exports (in Local Currency Unit) in Argentina in 1999 to that in 2003?
Your answer should be very brief. 0.29. What is the ratio of the Exports (in Local Currency Unit) of Bangladesh in 1999 to that in 2003?
Your response must be concise. 0.73. What is the ratio of the Exports (in Local Currency Unit) of Djibouti in 1999 to that in 2003?
Provide a short and direct response. 0.81. What is the ratio of the Exports (in Local Currency Unit) of Faeroe Islands in 1999 to that in 2003?
Your answer should be very brief. 0.83. What is the ratio of the Exports (in Local Currency Unit) in Bangladesh in 2000 to that in 2001?
Keep it short and to the point. 0.85. What is the ratio of the Exports (in Local Currency Unit) of Djibouti in 2000 to that in 2001?
Keep it short and to the point. 0.91. What is the ratio of the Exports (in Local Currency Unit) in Faeroe Islands in 2000 to that in 2001?
Your answer should be very brief. 0.9. What is the ratio of the Exports (in Local Currency Unit) of Argentina in 2000 to that in 2002?
Provide a short and direct response. 0.35. What is the ratio of the Exports (in Local Currency Unit) of Bangladesh in 2000 to that in 2002?
Ensure brevity in your answer.  0.85. What is the ratio of the Exports (in Local Currency Unit) in Djibouti in 2000 to that in 2002?
Offer a terse response. 0.85. What is the ratio of the Exports (in Local Currency Unit) of Faeroe Islands in 2000 to that in 2002?
Keep it short and to the point. 0.9. What is the ratio of the Exports (in Local Currency Unit) in Argentina in 2000 to that in 2003?
Give a very brief answer. 0.32. What is the ratio of the Exports (in Local Currency Unit) of Bangladesh in 2000 to that in 2003?
Make the answer very short. 0.83. What is the ratio of the Exports (in Local Currency Unit) of Djibouti in 2000 to that in 2003?
Provide a succinct answer. 0.78. What is the ratio of the Exports (in Local Currency Unit) in Faeroe Islands in 2000 to that in 2003?
Your answer should be very brief. 0.97. What is the ratio of the Exports (in Local Currency Unit) in Argentina in 2001 to that in 2002?
Give a very brief answer. 0.35. What is the ratio of the Exports (in Local Currency Unit) in Djibouti in 2001 to that in 2002?
Provide a succinct answer. 0.94. What is the ratio of the Exports (in Local Currency Unit) in Argentina in 2001 to that in 2003?
Your answer should be compact. 0.32. What is the ratio of the Exports (in Local Currency Unit) in Bangladesh in 2001 to that in 2003?
Offer a very short reply. 0.98. What is the ratio of the Exports (in Local Currency Unit) of Djibouti in 2001 to that in 2003?
Offer a very short reply. 0.86. What is the ratio of the Exports (in Local Currency Unit) in Faeroe Islands in 2001 to that in 2003?
Offer a terse response. 1.08. What is the ratio of the Exports (in Local Currency Unit) of Argentina in 2002 to that in 2003?
Provide a succinct answer. 0.91. What is the ratio of the Exports (in Local Currency Unit) in Bangladesh in 2002 to that in 2003?
Your answer should be very brief. 0.98. What is the ratio of the Exports (in Local Currency Unit) of Djibouti in 2002 to that in 2003?
Keep it short and to the point. 0.92. What is the ratio of the Exports (in Local Currency Unit) of Faeroe Islands in 2002 to that in 2003?
Your response must be concise. 1.07. What is the difference between the highest and the second highest Exports (in Local Currency Unit) in Argentina?
Provide a succinct answer. 8.76e+09. What is the difference between the highest and the second highest Exports (in Local Currency Unit) of Bangladesh?
Keep it short and to the point. 8.15e+09. What is the difference between the highest and the second highest Exports (in Local Currency Unit) in Djibouti?
Offer a very short reply. 3.60e+09. What is the difference between the highest and the second highest Exports (in Local Currency Unit) of Faeroe Islands?
Offer a very short reply. 2.40e+07. What is the difference between the highest and the lowest Exports (in Local Currency Unit) of Argentina?
Your answer should be very brief. 6.96e+1. What is the difference between the highest and the lowest Exports (in Local Currency Unit) of Bangladesh?
Provide a short and direct response. 1.31e+11. What is the difference between the highest and the lowest Exports (in Local Currency Unit) in Djibouti?
Your answer should be very brief. 9.78e+09. What is the difference between the highest and the lowest Exports (in Local Currency Unit) in Faeroe Islands?
Give a very brief answer. 1.46e+09. 